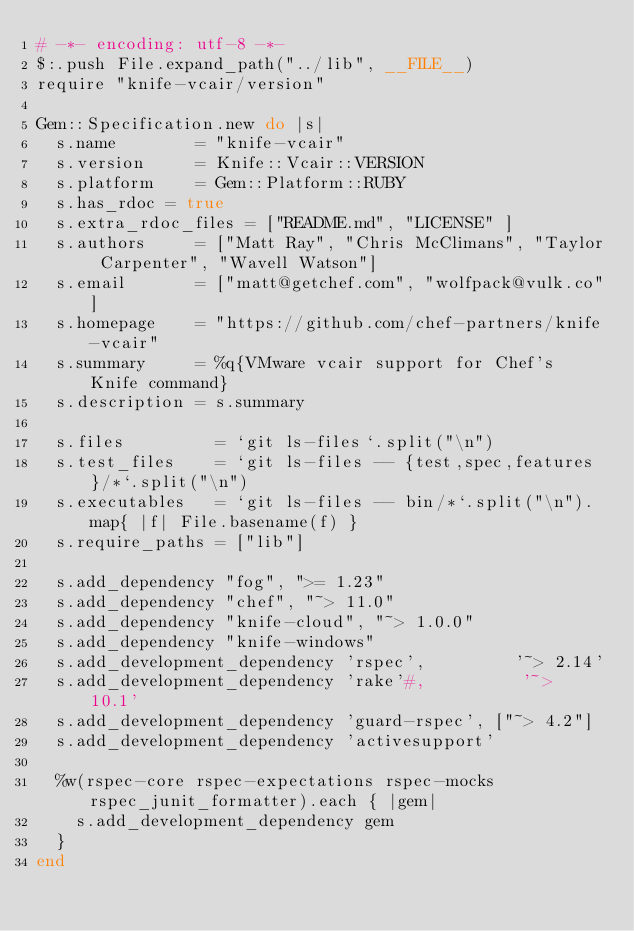Convert code to text. <code><loc_0><loc_0><loc_500><loc_500><_Ruby_># -*- encoding: utf-8 -*-
$:.push File.expand_path("../lib", __FILE__)
require "knife-vcair/version"

Gem::Specification.new do |s|
  s.name        = "knife-vcair"
  s.version     = Knife::Vcair::VERSION
  s.platform    = Gem::Platform::RUBY
  s.has_rdoc = true
  s.extra_rdoc_files = ["README.md", "LICENSE" ]
  s.authors     = ["Matt Ray", "Chris McClimans", "Taylor Carpenter", "Wavell Watson"]
  s.email       = ["matt@getchef.com", "wolfpack@vulk.co"]
  s.homepage    = "https://github.com/chef-partners/knife-vcair"
  s.summary     = %q{VMware vcair support for Chef's Knife command}
  s.description = s.summary

  s.files         = `git ls-files`.split("\n")
  s.test_files    = `git ls-files -- {test,spec,features}/*`.split("\n")
  s.executables   = `git ls-files -- bin/*`.split("\n").map{ |f| File.basename(f) }
  s.require_paths = ["lib"]

  s.add_dependency "fog", ">= 1.23"
  s.add_dependency "chef", "~> 11.0"
  s.add_dependency "knife-cloud", "~> 1.0.0"
  s.add_dependency "knife-windows"
  s.add_development_dependency 'rspec',         '~> 2.14'
  s.add_development_dependency 'rake'#,          '~> 10.1'
  s.add_development_dependency 'guard-rspec', ["~> 4.2"]
  s.add_development_dependency 'activesupport'

  %w(rspec-core rspec-expectations rspec-mocks rspec_junit_formatter).each { |gem|
    s.add_development_dependency gem
  }
end
</code> 